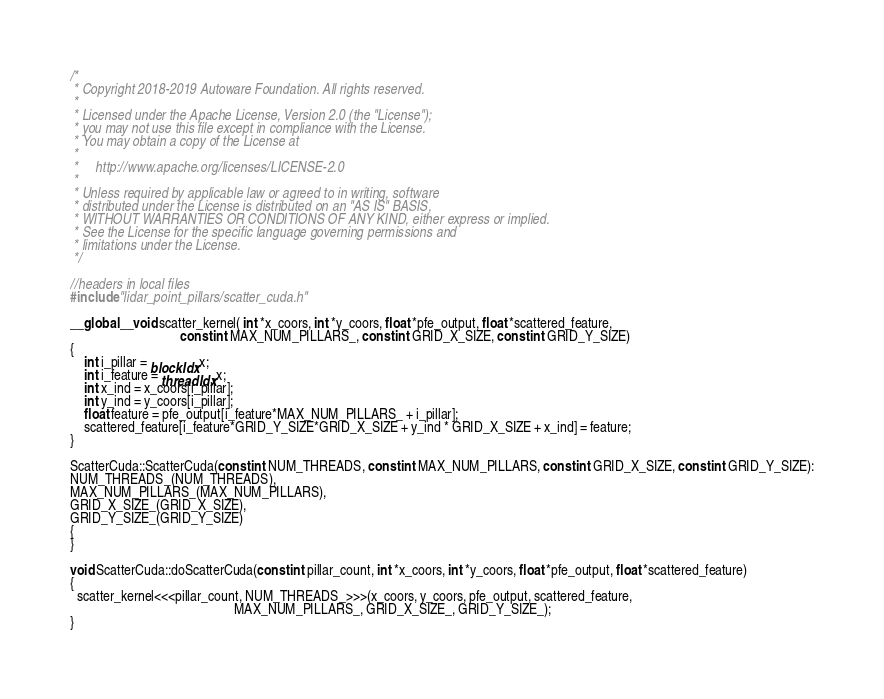<code> <loc_0><loc_0><loc_500><loc_500><_Cuda_>/*
 * Copyright 2018-2019 Autoware Foundation. All rights reserved.
 *
 * Licensed under the Apache License, Version 2.0 (the "License");
 * you may not use this file except in compliance with the License.
 * You may obtain a copy of the License at
 *
 *     http://www.apache.org/licenses/LICENSE-2.0
 *
 * Unless required by applicable law or agreed to in writing, software
 * distributed under the License is distributed on an "AS IS" BASIS,
 * WITHOUT WARRANTIES OR CONDITIONS OF ANY KIND, either express or implied.
 * See the License for the specific language governing permissions and
 * limitations under the License.
 */

//headers in local files
#include "lidar_point_pillars/scatter_cuda.h"

__global__ void scatter_kernel( int *x_coors, int *y_coors, float *pfe_output, float *scattered_feature,
                                const int MAX_NUM_PILLARS_, const int GRID_X_SIZE, const int GRID_Y_SIZE)
{
    int i_pillar = blockIdx.x;
    int i_feature = threadIdx.x;
    int x_ind = x_coors[i_pillar];
    int y_ind = y_coors[i_pillar];
    float feature = pfe_output[i_feature*MAX_NUM_PILLARS_ + i_pillar];
    scattered_feature[i_feature*GRID_Y_SIZE*GRID_X_SIZE + y_ind * GRID_X_SIZE + x_ind] = feature;
}

ScatterCuda::ScatterCuda(const int NUM_THREADS, const int MAX_NUM_PILLARS, const int GRID_X_SIZE, const int GRID_Y_SIZE):
NUM_THREADS_(NUM_THREADS),
MAX_NUM_PILLARS_(MAX_NUM_PILLARS),
GRID_X_SIZE_(GRID_X_SIZE),
GRID_Y_SIZE_(GRID_Y_SIZE)
{
}

void ScatterCuda::doScatterCuda(const int pillar_count, int *x_coors, int *y_coors, float *pfe_output, float *scattered_feature)
{
  scatter_kernel<<<pillar_count, NUM_THREADS_>>>(x_coors, y_coors, pfe_output, scattered_feature,
                                                MAX_NUM_PILLARS_, GRID_X_SIZE_, GRID_Y_SIZE_);
}
</code> 